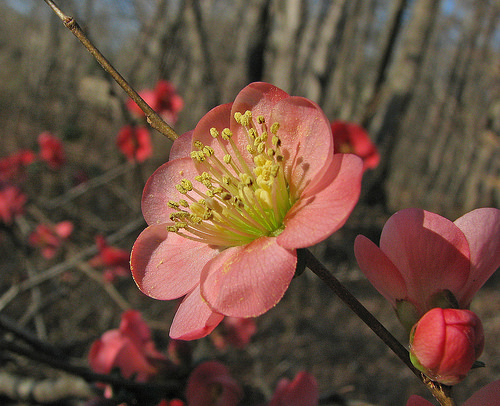<image>
Can you confirm if the flower is next to the stem? Yes. The flower is positioned adjacent to the stem, located nearby in the same general area. 